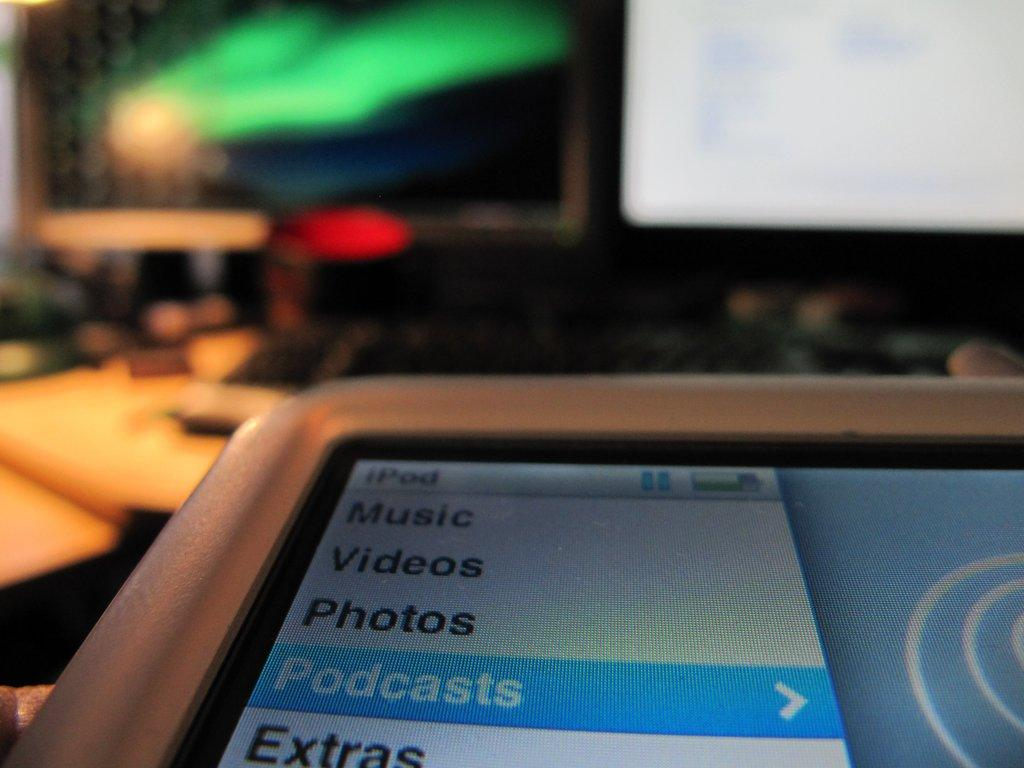<image>
Write a terse but informative summary of the picture. close up of an ipod screen showing menu for music, videos, photos, podcasts, and extras 